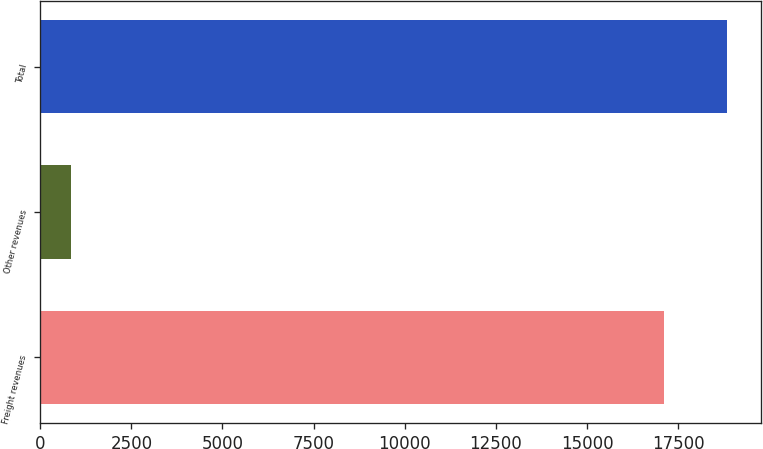<chart> <loc_0><loc_0><loc_500><loc_500><bar_chart><fcel>Freight revenues<fcel>Other revenues<fcel>Total<nl><fcel>17118<fcel>852<fcel>18829.8<nl></chart> 